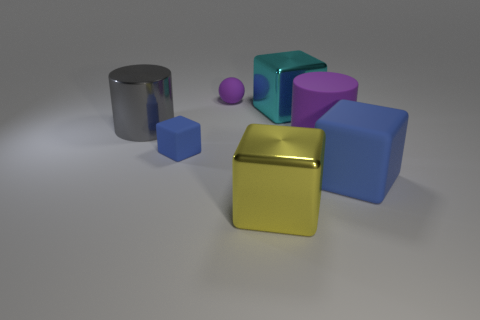Is the number of large yellow shiny objects that are on the left side of the large gray metal cylinder greater than the number of small brown rubber things?
Keep it short and to the point. No. There is a sphere to the left of the big metal object in front of the tiny block; are there any balls that are in front of it?
Provide a succinct answer. No. Are there any large metal cylinders on the right side of the small purple matte ball?
Ensure brevity in your answer.  No. How many small matte spheres are the same color as the rubber cylinder?
Give a very brief answer. 1. There is a purple object that is made of the same material as the large purple cylinder; what size is it?
Make the answer very short. Small. There is a purple matte object on the left side of the big metal cube in front of the large block to the right of the large cyan shiny object; what is its size?
Provide a succinct answer. Small. How big is the thing on the right side of the purple rubber cylinder?
Offer a very short reply. Large. What number of gray things are either metal cubes or rubber things?
Your response must be concise. 0. Are there any shiny balls of the same size as the gray object?
Offer a terse response. No. What material is the block that is the same size as the ball?
Provide a succinct answer. Rubber. 